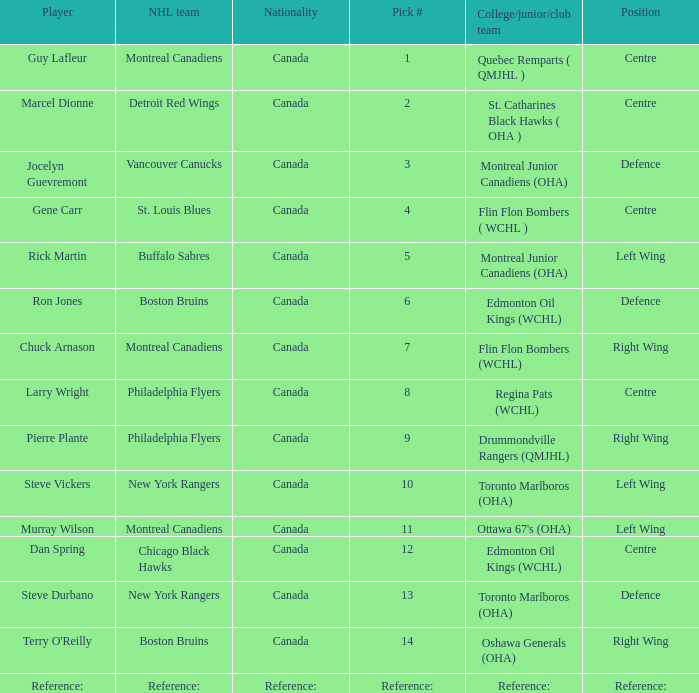Which College/junior/club team has a Pick # of 1? Quebec Remparts ( QMJHL ). 